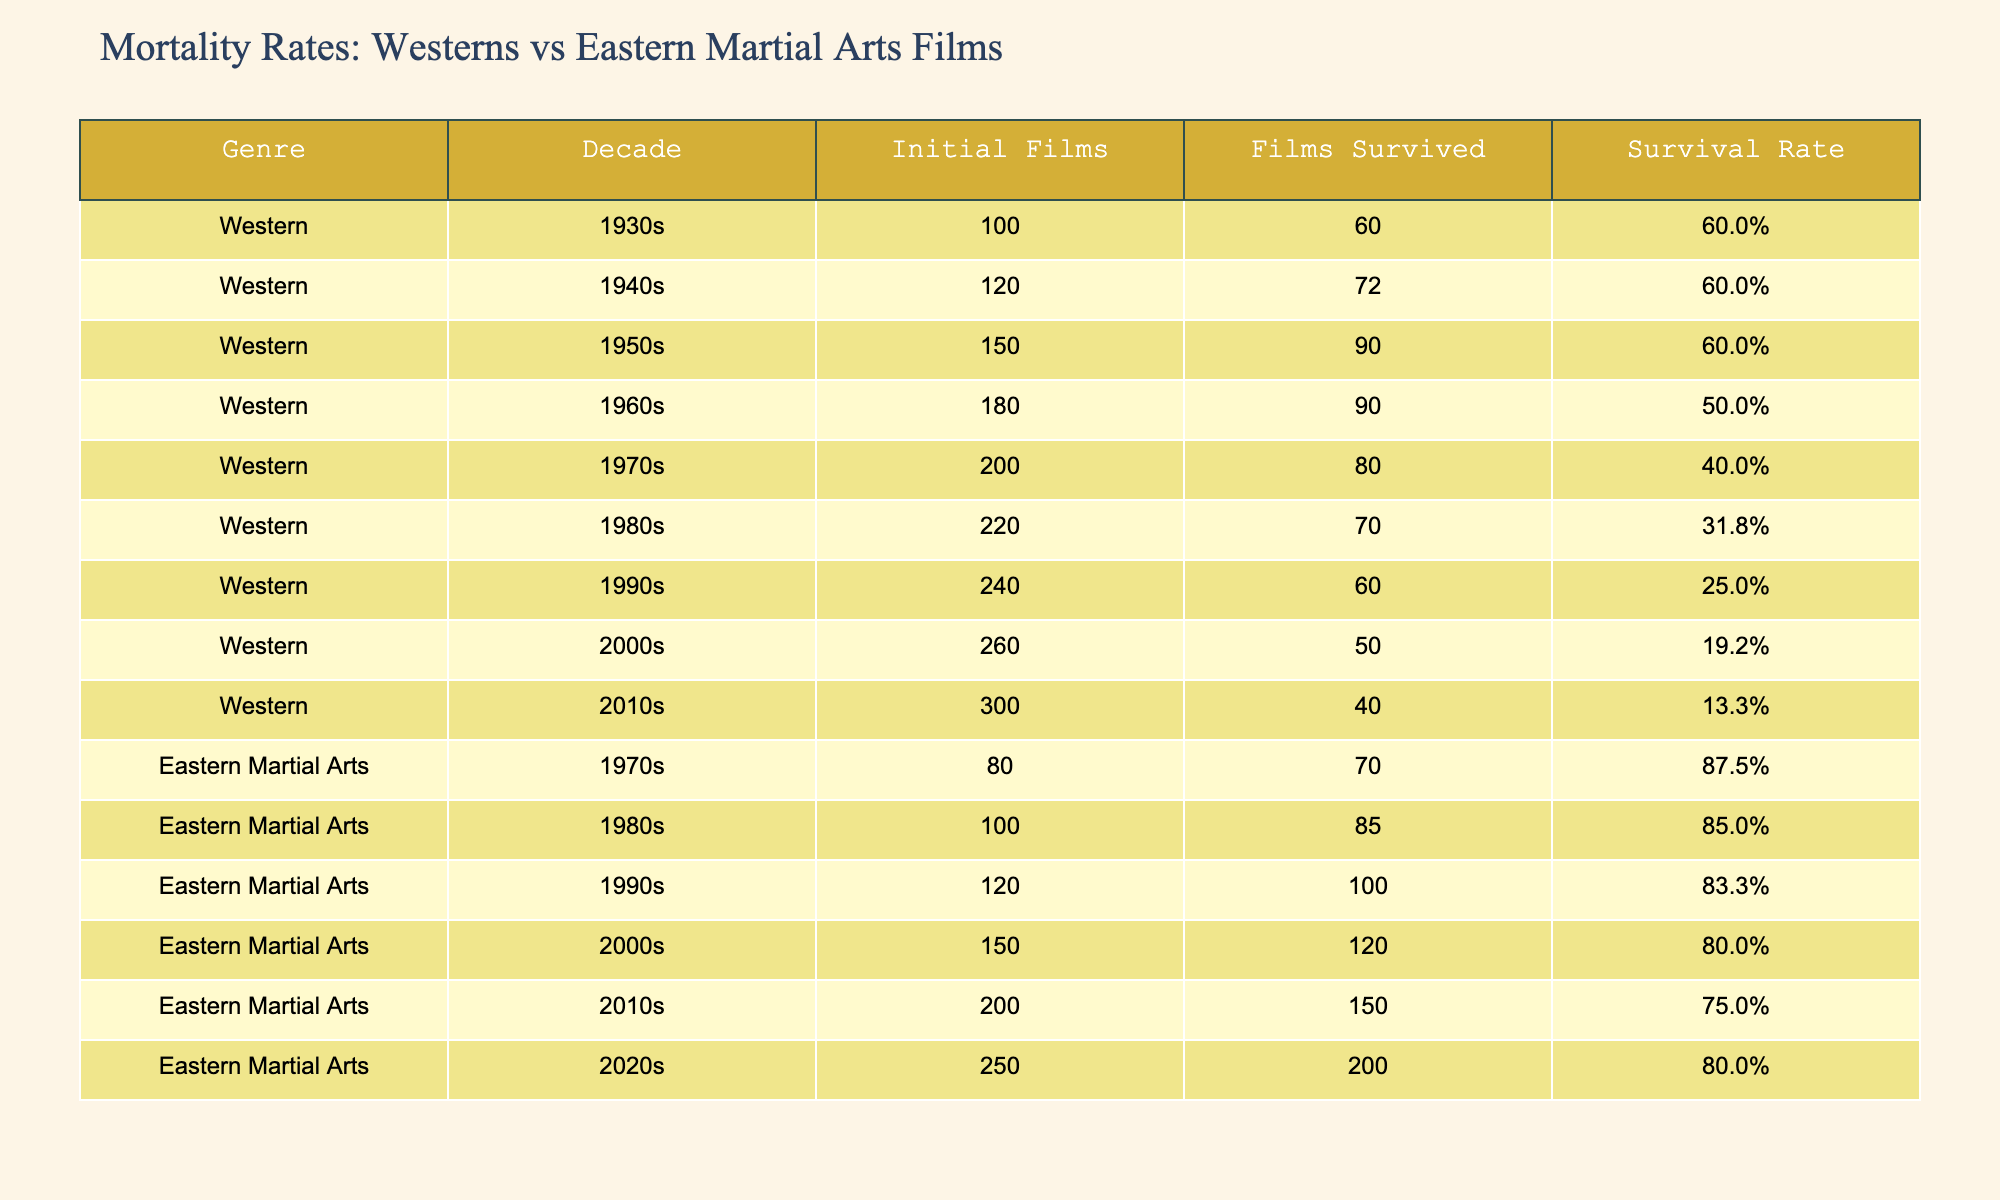What is the survival rate of Western films in the 1980s? The table shows that the survival rate for Western films in the 1980s is 31.8%. This is directly found in the corresponding row for that decade under the Survival Rate column.
Answer: 31.8% How many Eastern martial arts films survived in the 2000s? According to the table, 120 Eastern martial arts films survived in the 2000s, as indicated in the Films Survived column for that decade.
Answer: 120 What is the difference in survival rates between Westerns in the 1990s and Eastern martial arts films in the 1990s? The survival rate for Western films in the 1990s is 25.0%, and for Eastern martial arts films in the same decade, it is 83.3%. The difference is calculated as 83.3% - 25.0% = 58.3%.
Answer: 58.3% Did the survival rate of Western films decline over the decades? Analyzing the table shows that the survival rates for Westerns decreased from 60.0% in the 1930s to 13.3% in the 2010s. This indicates a decline in survival rates over the decades.
Answer: Yes What was the highest survival rate for Western films across all decades? The table indicates that the highest survival rate for Western films was 60.0%, which occurred in the 1930s, 1940s, and 1950s. By checking the values in the Survival Rate column, we find these rates are the largest compared to other decades.
Answer: 60.0% What was the average survival rate of Eastern martial arts films from the 1970s to the 2020s? The survival rates for Eastern martial arts films across decades are as follows: 87.5% (1970s), 85.0% (1980s), 83.3% (1990s), 80.0% (2000s), 75.0% (2010s), and 80.0% (2020s). Adding these survival rates gives us 87.5 + 85.0 + 83.3 + 80.0 + 75.0 + 80.0 = 500.8%. Dividing by the number of decades (6) gives an average of 500.8/6 = 83.47%.
Answer: 83.47% How many Western films were produced in the 1960s? The data indicates that there were 180 Western films produced in the 1960s, as stated in the Initial Films column under that decade.
Answer: 180 Have survival rates for Eastern martial arts films ever dropped below 75%? The table shows that the survival rate for Eastern martial arts films dropped to 75.0% only in the 2010s, but it did not drop below 75% in the following decade, which is the 2020s at 80.0%. Therefore, the rates either remained the same or increased afterward.
Answer: No 